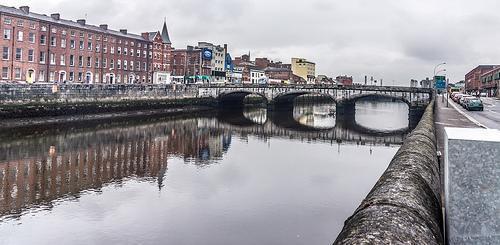How many arches are on the bridge?
Give a very brief answer. 3. 